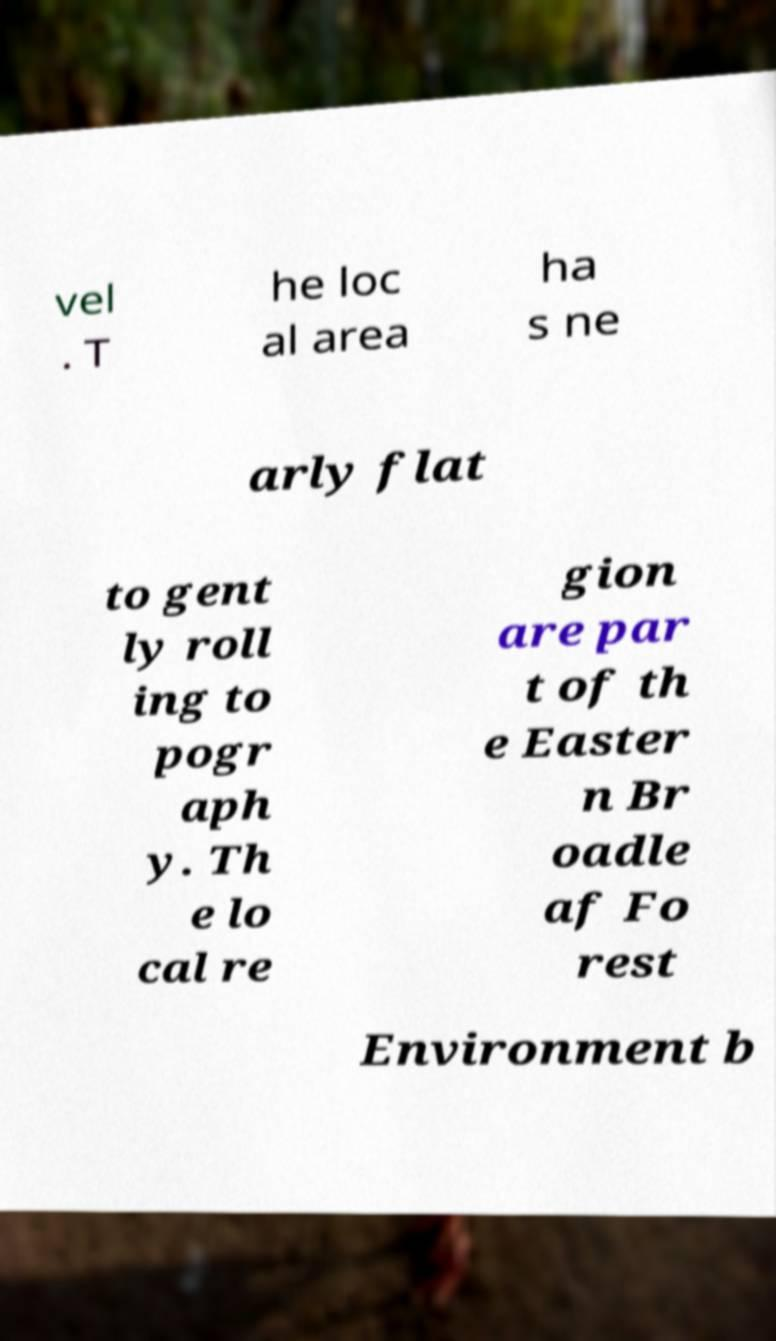Please read and relay the text visible in this image. What does it say? vel . T he loc al area ha s ne arly flat to gent ly roll ing to pogr aph y. Th e lo cal re gion are par t of th e Easter n Br oadle af Fo rest Environment b 